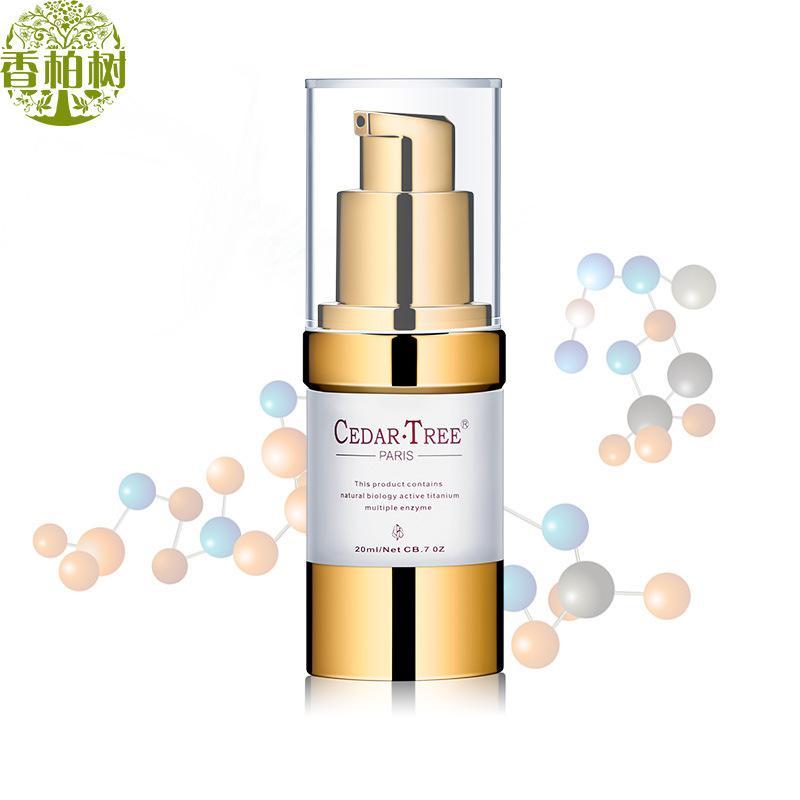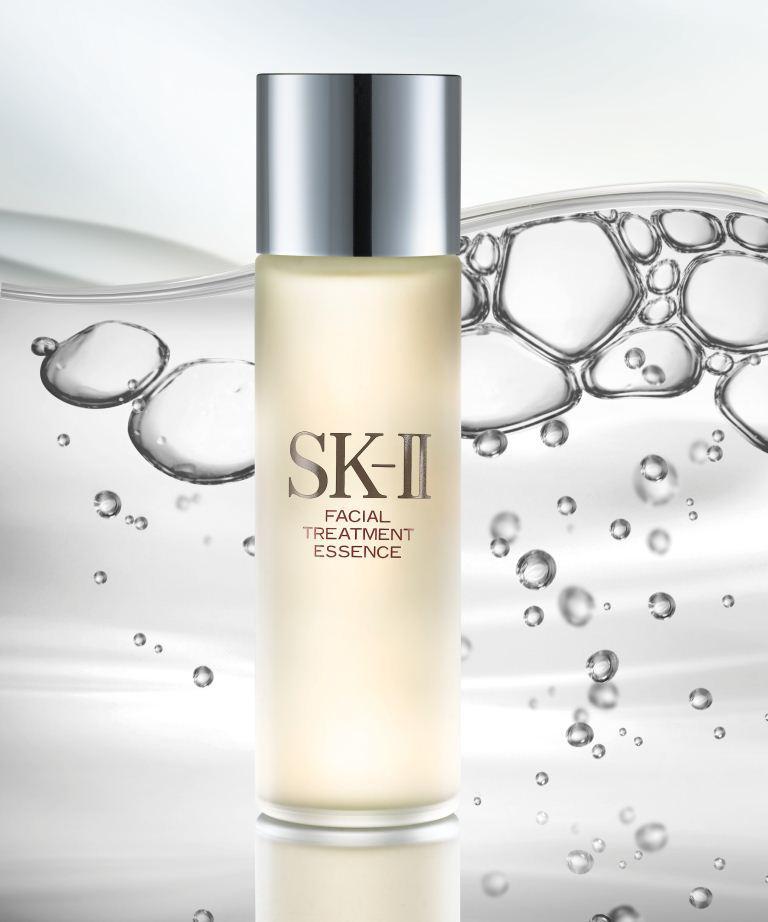The first image is the image on the left, the second image is the image on the right. Examine the images to the left and right. Is the description "There are a total of two beauty product containers." accurate? Answer yes or no. Yes. The first image is the image on the left, the second image is the image on the right. For the images shown, is this caption "One image shows a single bottle with its applicator top next to it." true? Answer yes or no. No. 